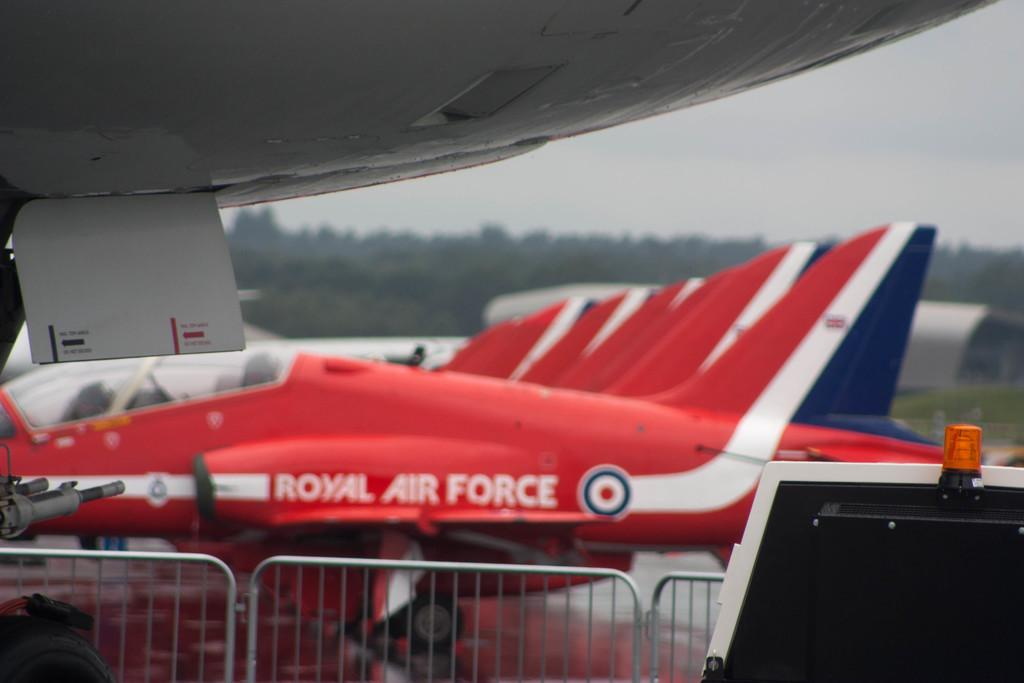<image>
Share a concise interpretation of the image provided. royal air force planes are lined up in a straight line 